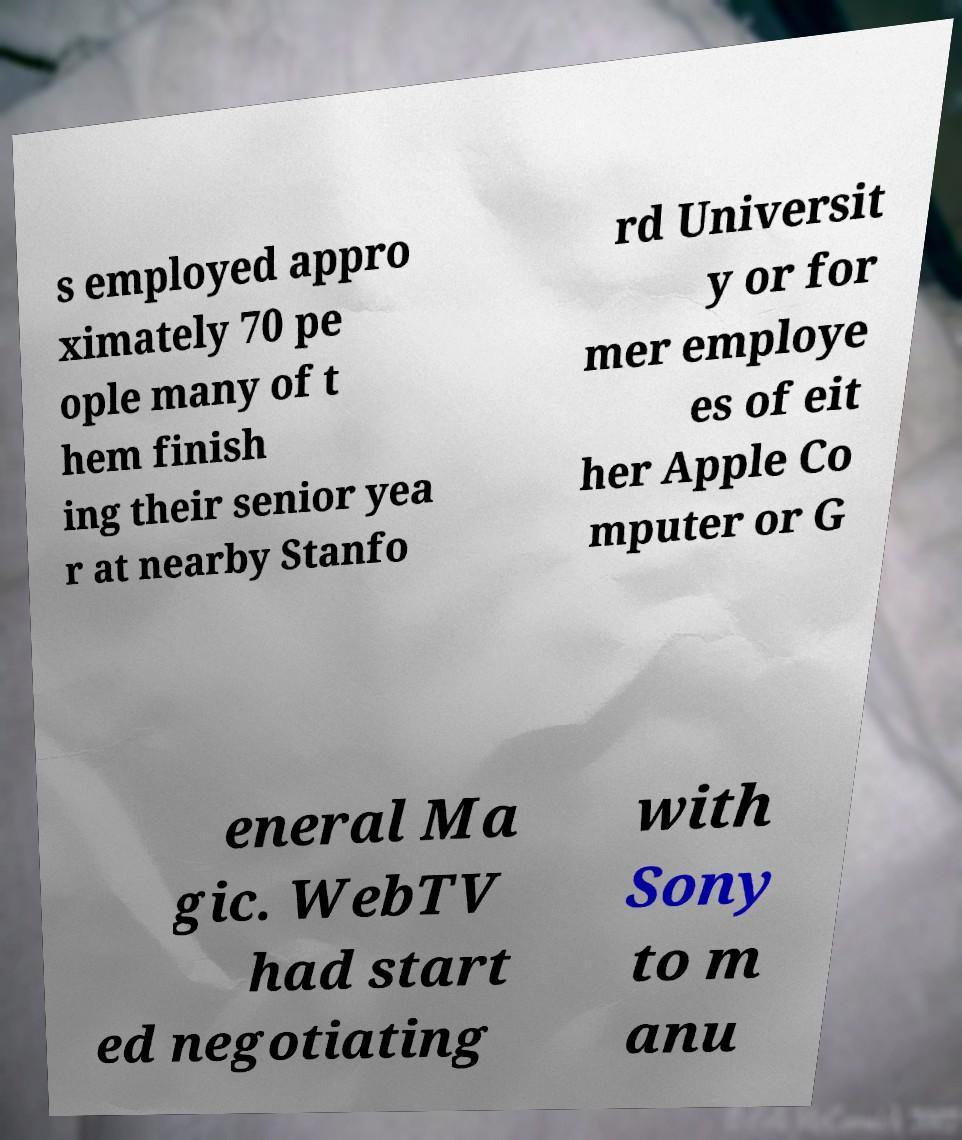What messages or text are displayed in this image? I need them in a readable, typed format. s employed appro ximately 70 pe ople many of t hem finish ing their senior yea r at nearby Stanfo rd Universit y or for mer employe es of eit her Apple Co mputer or G eneral Ma gic. WebTV had start ed negotiating with Sony to m anu 